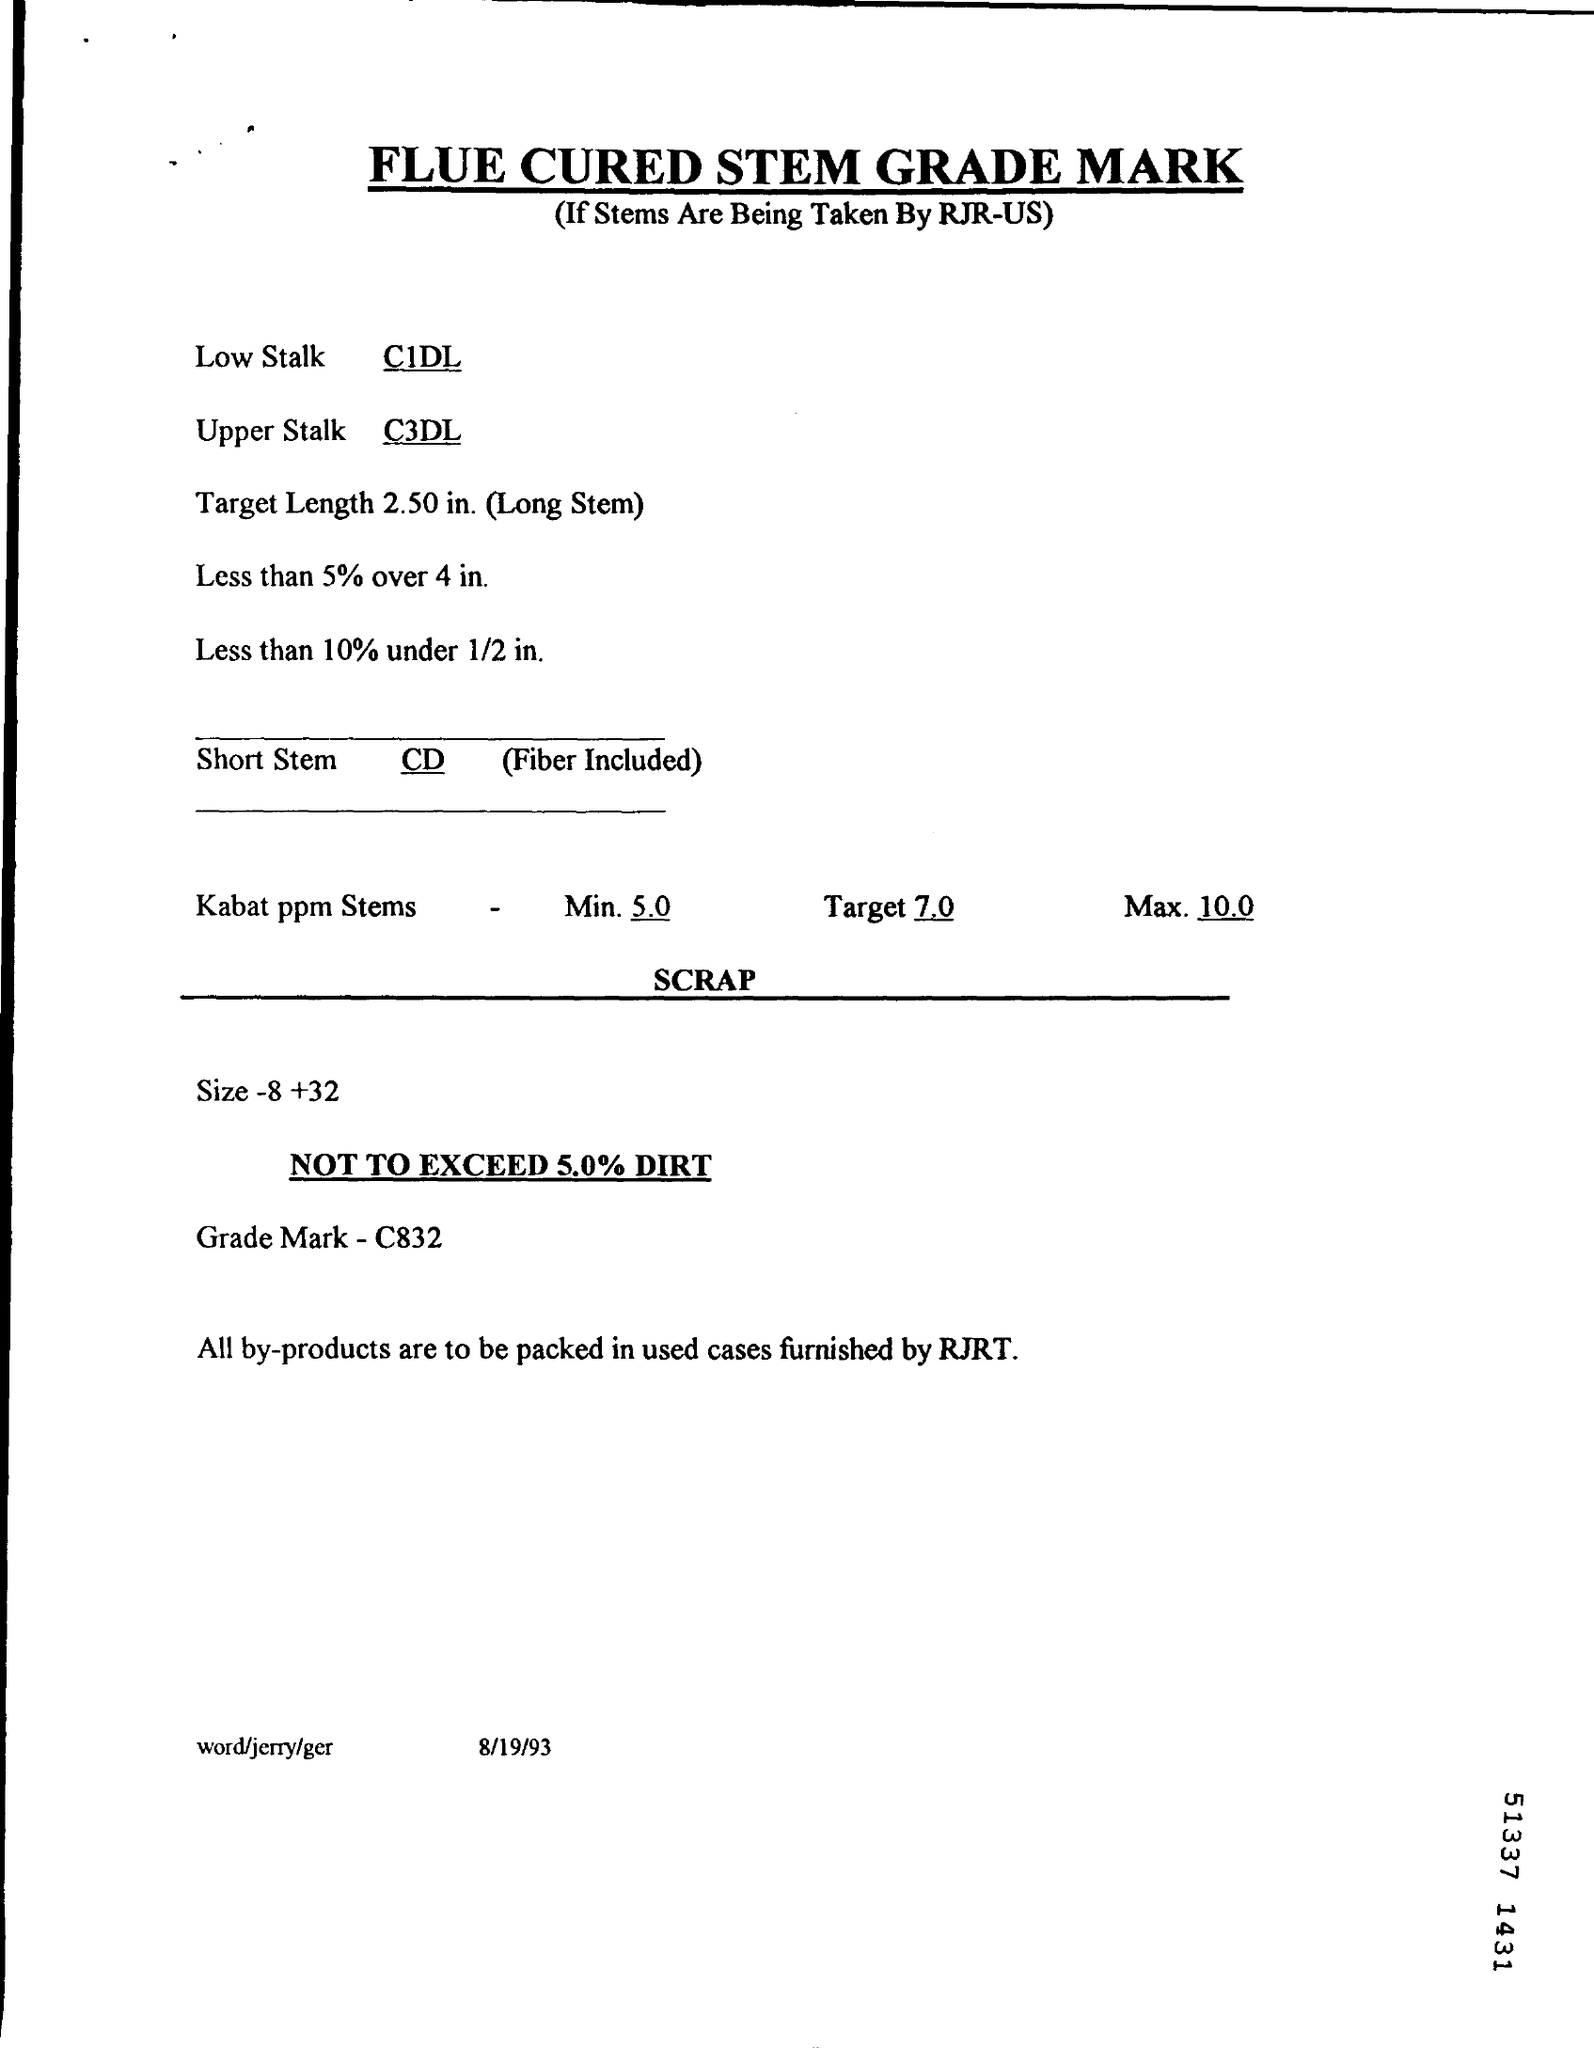When is the document dated?
Offer a terse response. 8/19/93. What is the grade mark mentioned?
Make the answer very short. C832. 